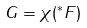Convert formula to latex. <formula><loc_0><loc_0><loc_500><loc_500>G = \chi ( ^ { * } F )</formula> 